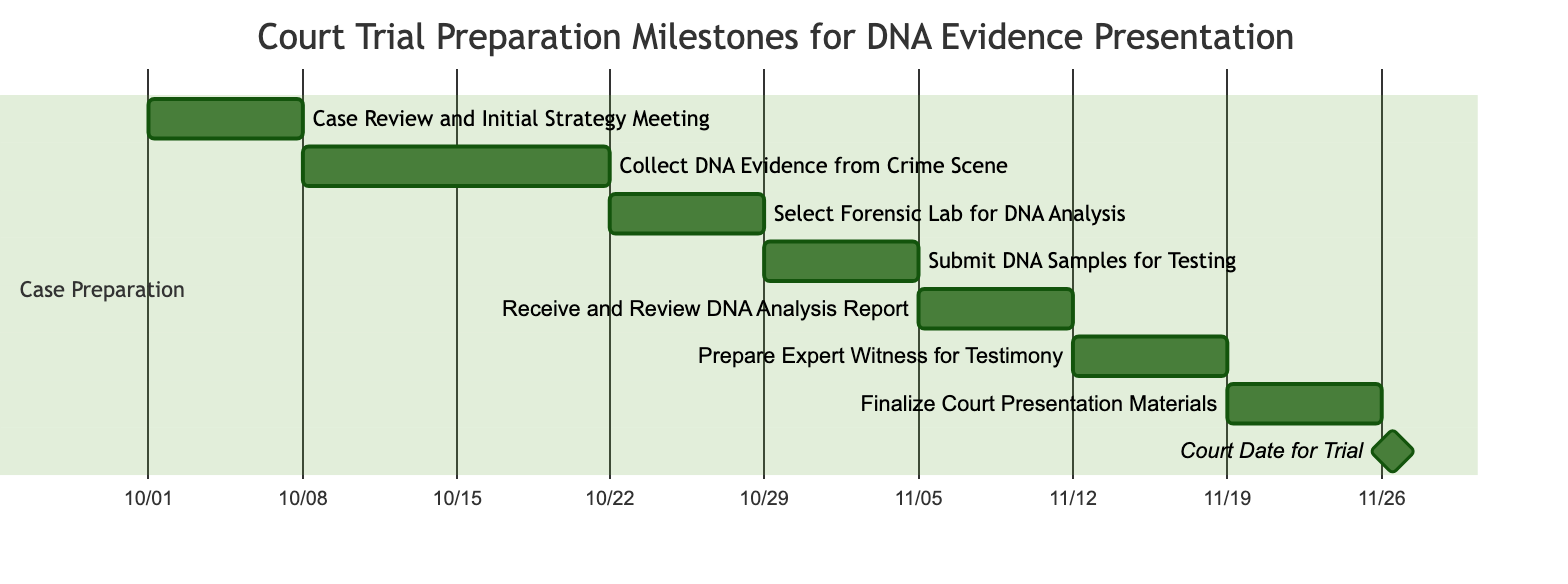What is the duration of the "Collect DNA Evidence from Crime Scene" task? The diagram specifies that the "Collect DNA Evidence from Crime Scene" task lasts for 2 weeks as indicated by the duration labeled next to the task.
Answer: 2 weeks When does the "Finalize Court Presentation Materials" task start? By reviewing the timeline in the diagram, the "Finalize Court Presentation Materials" task starts on "2023-11-19", which is after the completion of the preceding task "Prepare Expert Witness for Testimony".
Answer: 2023-11-19 How many tasks are there in the preparation phase? Counting the tasks listed in the "Case Preparation" section of the diagram, there are a total of 8 tasks represented, starting from the case review to the court date.
Answer: 8 Which task follows the "Submit DNA Samples for Testing"? The flow of the diagram indicates that the task that immediately follows "Submit DNA Samples for Testing" is "Receive and Review DNA Analysis Report", connected in a sequential manner.
Answer: Receive and Review DNA Analysis Report What is the end date for the "Court Date for Trial"? The end date for the "Court Date for Trial" task is shown as "2023-11-26", which is a specific day marked as the trial date in the diagram.
Answer: 2023-11-26 What task has the shortest duration? By analyzing the durations of all tasks in the diagram, the "Court Date for Trial" task has the shortest duration of just 1 day, as marked in the timeline.
Answer: 1 day Which task is the last one before the trial date? The task immediately preceding the "Court Date for Trial" is "Finalize Court Presentation Materials", which is shown in the diagram as the last task in the sequence before the trial.
Answer: Finalize Court Presentation Materials What is the total duration from the start of the first task to the end of the last task? To determine the total duration, we calculate from the start date of the first task on "2023-10-01" to the end date of the last task, which is "2023-11-26". This gives a span of approximately 8 weeks.
Answer: 8 weeks 